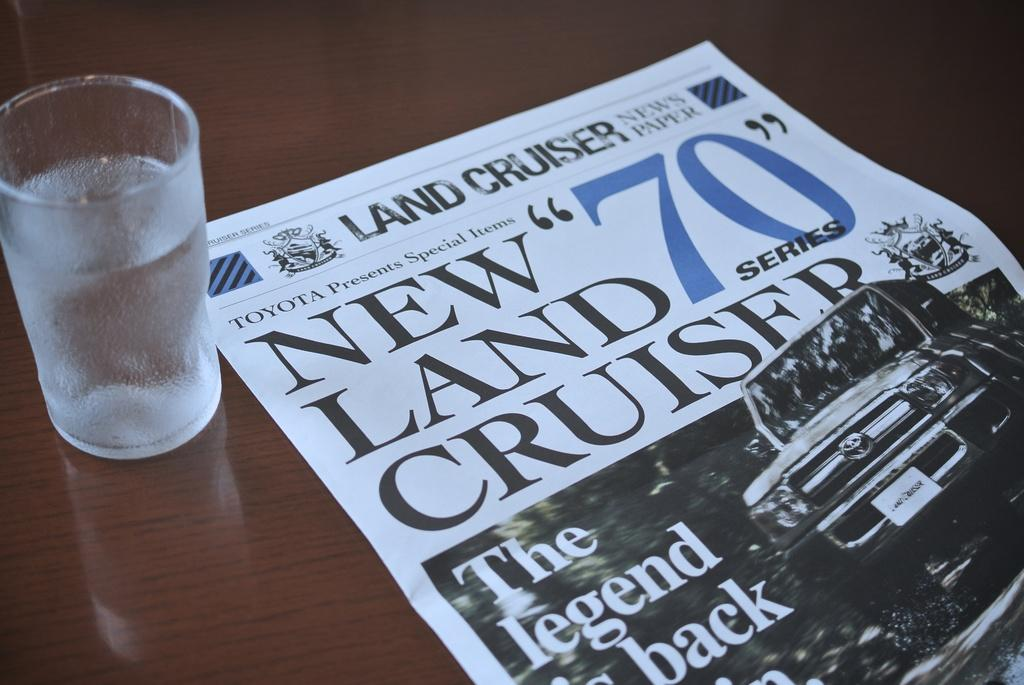<image>
Summarize the visual content of the image. The Land Cruiser newspaper has a large 70 on the front page above a vehicle. 